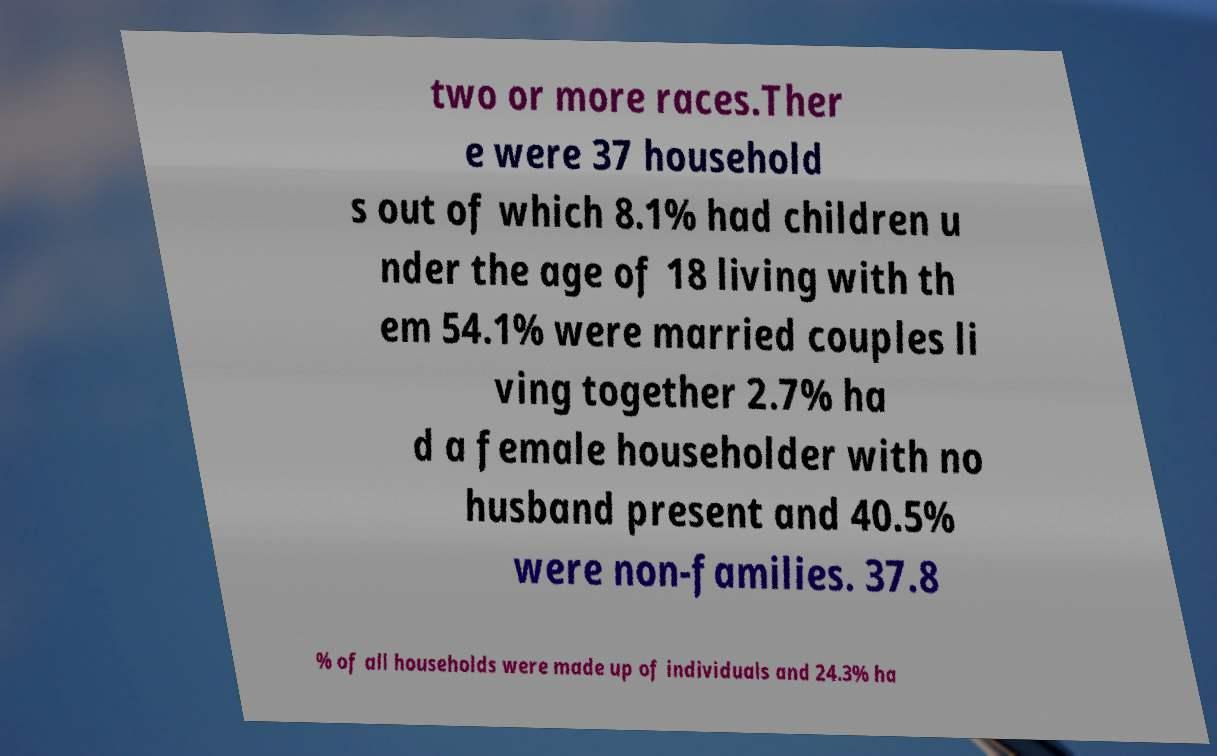There's text embedded in this image that I need extracted. Can you transcribe it verbatim? two or more races.Ther e were 37 household s out of which 8.1% had children u nder the age of 18 living with th em 54.1% were married couples li ving together 2.7% ha d a female householder with no husband present and 40.5% were non-families. 37.8 % of all households were made up of individuals and 24.3% ha 